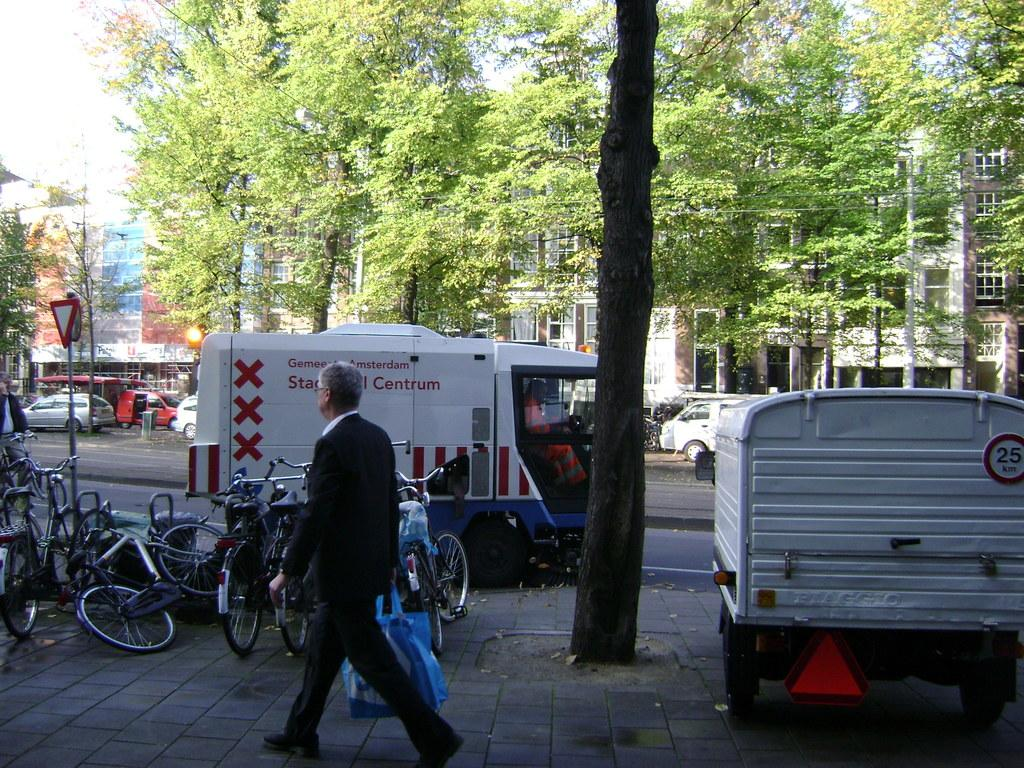What type of structures can be seen in the image? There are buildings in the image. What mode of transportation can be seen on the road? Motor vehicles are present on the road. What alternative mode of transportation is visible beside the road? Bicycles are beside the road. What can be found on the ground in the image? Shredded leaves are visible. What are the people in the image doing? Persons are walking on the road. What type of signs are present in the image? Sign boards are present. What type of natural elements can be seen in the image? Trees are visible in the image. What part of the environment is visible in the image? The sky is visible in the image. How many sisters are sitting on the shelf in the image? There is no shelf or sisters present in the image. What color is the sky in the image? The provided facts do not mention the color of the sky, only that it is visible. 